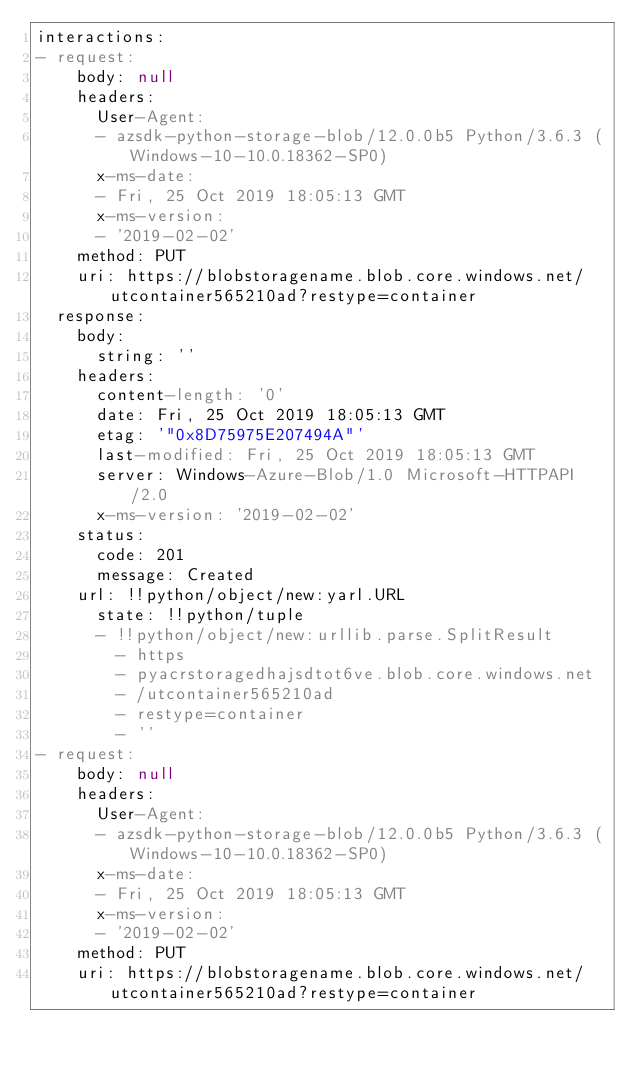Convert code to text. <code><loc_0><loc_0><loc_500><loc_500><_YAML_>interactions:
- request:
    body: null
    headers:
      User-Agent:
      - azsdk-python-storage-blob/12.0.0b5 Python/3.6.3 (Windows-10-10.0.18362-SP0)
      x-ms-date:
      - Fri, 25 Oct 2019 18:05:13 GMT
      x-ms-version:
      - '2019-02-02'
    method: PUT
    uri: https://blobstoragename.blob.core.windows.net/utcontainer565210ad?restype=container
  response:
    body:
      string: ''
    headers:
      content-length: '0'
      date: Fri, 25 Oct 2019 18:05:13 GMT
      etag: '"0x8D75975E207494A"'
      last-modified: Fri, 25 Oct 2019 18:05:13 GMT
      server: Windows-Azure-Blob/1.0 Microsoft-HTTPAPI/2.0
      x-ms-version: '2019-02-02'
    status:
      code: 201
      message: Created
    url: !!python/object/new:yarl.URL
      state: !!python/tuple
      - !!python/object/new:urllib.parse.SplitResult
        - https
        - pyacrstoragedhajsdtot6ve.blob.core.windows.net
        - /utcontainer565210ad
        - restype=container
        - ''
- request:
    body: null
    headers:
      User-Agent:
      - azsdk-python-storage-blob/12.0.0b5 Python/3.6.3 (Windows-10-10.0.18362-SP0)
      x-ms-date:
      - Fri, 25 Oct 2019 18:05:13 GMT
      x-ms-version:
      - '2019-02-02'
    method: PUT
    uri: https://blobstoragename.blob.core.windows.net/utcontainer565210ad?restype=container</code> 